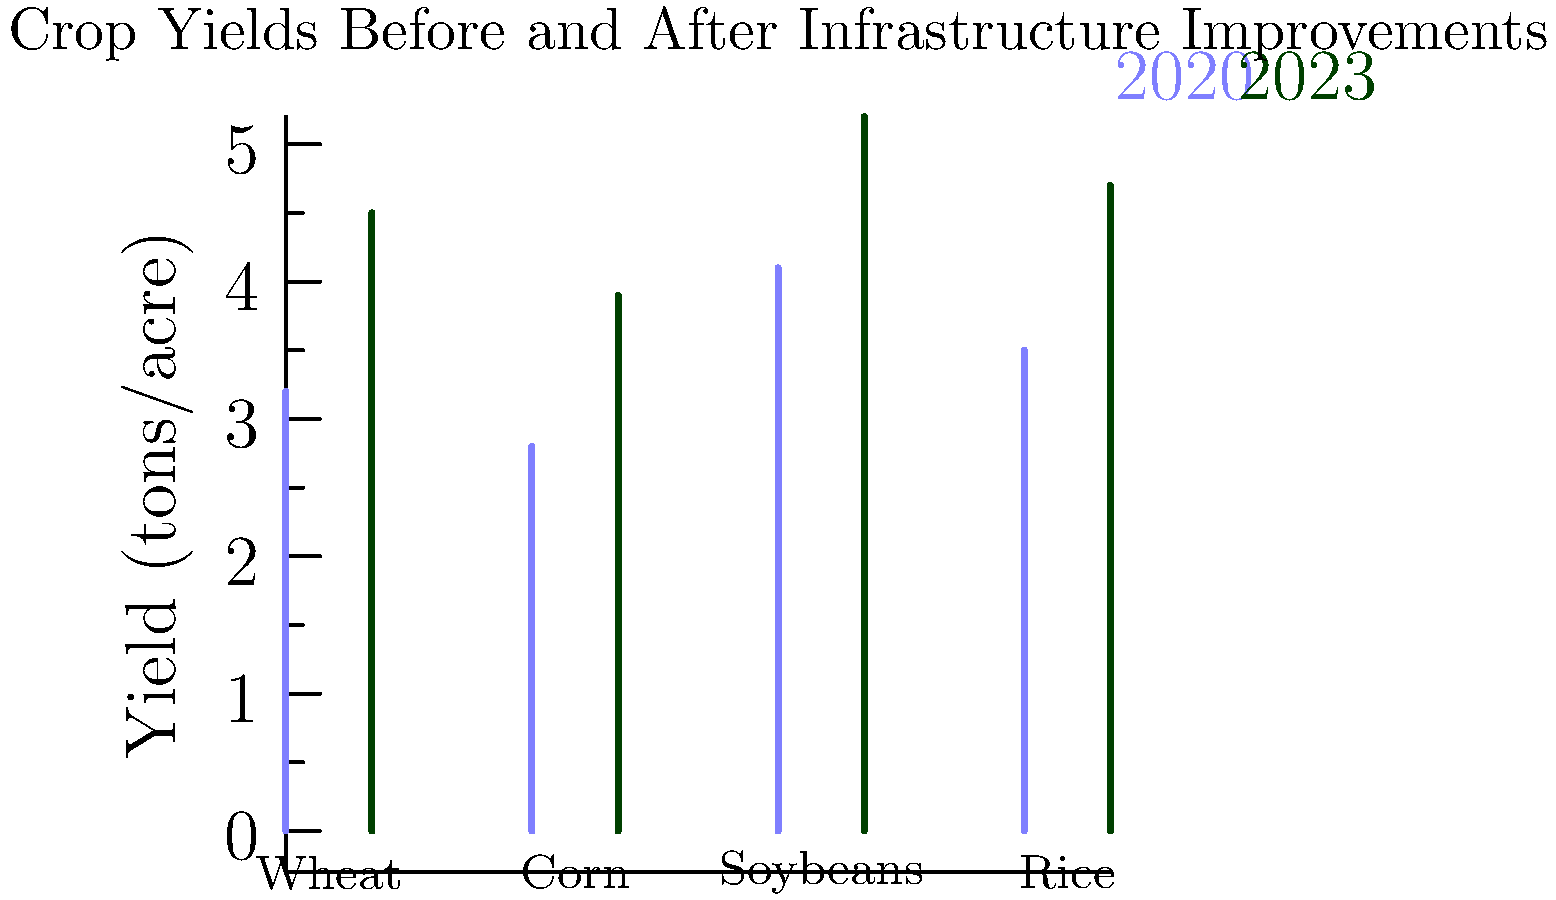Based on the bar graph comparing crop yields in 2020 and 2023, which crop showed the highest percentage increase in yield after infrastructure improvements? To determine which crop had the highest percentage increase, we need to calculate the percentage change for each crop:

1. Wheat:
   2020 yield: 3.2 tons/acre
   2023 yield: 4.5 tons/acre
   Percentage increase = $(4.5 - 3.2) / 3.2 \times 100\% = 40.63\%$

2. Corn:
   2020 yield: 2.8 tons/acre
   2023 yield: 3.9 tons/acre
   Percentage increase = $(3.9 - 2.8) / 2.8 \times 100\% = 39.29\%$

3. Soybeans:
   2020 yield: 4.1 tons/acre
   2023 yield: 5.2 tons/acre
   Percentage increase = $(5.2 - 4.1) / 4.1 \times 100\% = 26.83\%$

4. Rice:
   2020 yield: 3.5 tons/acre
   2023 yield: 4.7 tons/acre
   Percentage increase = $(4.7 - 3.5) / 3.5 \times 100\% = 34.29\%$

Comparing these percentages, we can see that wheat had the highest percentage increase at 40.63%.
Answer: Wheat 